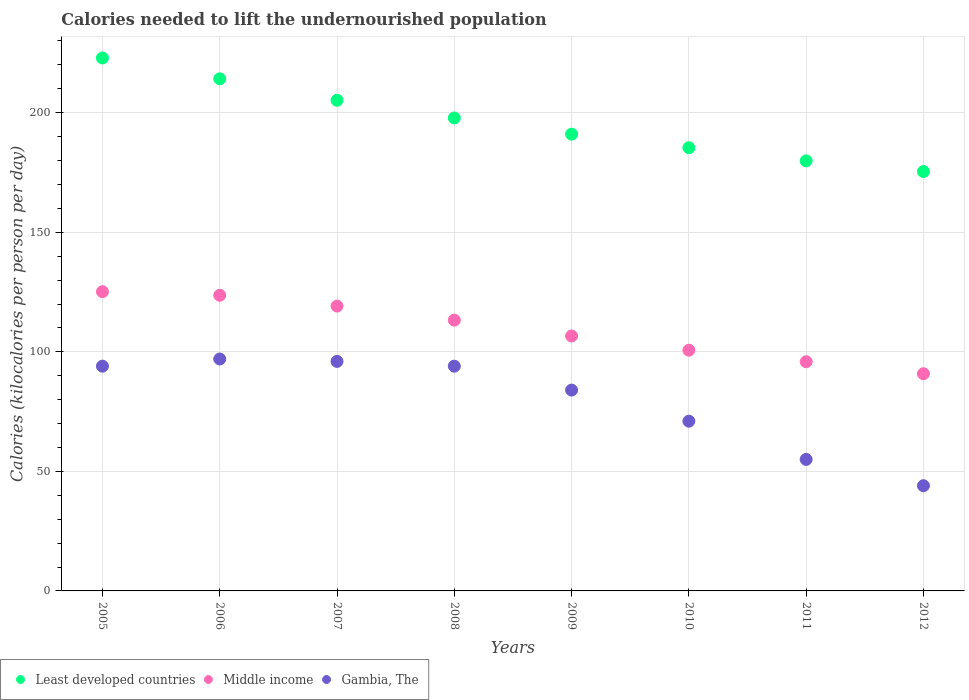How many different coloured dotlines are there?
Provide a succinct answer. 3. What is the total calories needed to lift the undernourished population in Least developed countries in 2010?
Your response must be concise. 185.38. Across all years, what is the maximum total calories needed to lift the undernourished population in Least developed countries?
Your answer should be compact. 222.9. Across all years, what is the minimum total calories needed to lift the undernourished population in Least developed countries?
Offer a terse response. 175.4. In which year was the total calories needed to lift the undernourished population in Gambia, The minimum?
Give a very brief answer. 2012. What is the total total calories needed to lift the undernourished population in Middle income in the graph?
Provide a short and direct response. 875.21. What is the difference between the total calories needed to lift the undernourished population in Gambia, The in 2008 and that in 2010?
Offer a very short reply. 23. What is the difference between the total calories needed to lift the undernourished population in Least developed countries in 2011 and the total calories needed to lift the undernourished population in Gambia, The in 2007?
Make the answer very short. 83.88. What is the average total calories needed to lift the undernourished population in Gambia, The per year?
Ensure brevity in your answer.  79.38. In the year 2010, what is the difference between the total calories needed to lift the undernourished population in Least developed countries and total calories needed to lift the undernourished population in Gambia, The?
Offer a very short reply. 114.38. What is the ratio of the total calories needed to lift the undernourished population in Gambia, The in 2010 to that in 2011?
Offer a very short reply. 1.29. Is the difference between the total calories needed to lift the undernourished population in Least developed countries in 2008 and 2009 greater than the difference between the total calories needed to lift the undernourished population in Gambia, The in 2008 and 2009?
Offer a terse response. No. What is the difference between the highest and the second highest total calories needed to lift the undernourished population in Gambia, The?
Offer a terse response. 1. What is the difference between the highest and the lowest total calories needed to lift the undernourished population in Least developed countries?
Keep it short and to the point. 47.5. In how many years, is the total calories needed to lift the undernourished population in Middle income greater than the average total calories needed to lift the undernourished population in Middle income taken over all years?
Provide a short and direct response. 4. Is the total calories needed to lift the undernourished population in Gambia, The strictly greater than the total calories needed to lift the undernourished population in Middle income over the years?
Your answer should be compact. No. Is the total calories needed to lift the undernourished population in Least developed countries strictly less than the total calories needed to lift the undernourished population in Gambia, The over the years?
Make the answer very short. No. How many dotlines are there?
Provide a short and direct response. 3. Does the graph contain any zero values?
Provide a short and direct response. No. Where does the legend appear in the graph?
Your answer should be compact. Bottom left. How many legend labels are there?
Keep it short and to the point. 3. What is the title of the graph?
Your answer should be compact. Calories needed to lift the undernourished population. What is the label or title of the Y-axis?
Your answer should be very brief. Calories (kilocalories per person per day). What is the Calories (kilocalories per person per day) in Least developed countries in 2005?
Give a very brief answer. 222.9. What is the Calories (kilocalories per person per day) in Middle income in 2005?
Provide a succinct answer. 125.16. What is the Calories (kilocalories per person per day) of Gambia, The in 2005?
Your answer should be very brief. 94. What is the Calories (kilocalories per person per day) in Least developed countries in 2006?
Your response must be concise. 214.18. What is the Calories (kilocalories per person per day) in Middle income in 2006?
Give a very brief answer. 123.65. What is the Calories (kilocalories per person per day) of Gambia, The in 2006?
Give a very brief answer. 97. What is the Calories (kilocalories per person per day) in Least developed countries in 2007?
Give a very brief answer. 205.2. What is the Calories (kilocalories per person per day) of Middle income in 2007?
Your answer should be very brief. 119.14. What is the Calories (kilocalories per person per day) of Gambia, The in 2007?
Offer a very short reply. 96. What is the Calories (kilocalories per person per day) of Least developed countries in 2008?
Your answer should be compact. 197.82. What is the Calories (kilocalories per person per day) in Middle income in 2008?
Offer a terse response. 113.26. What is the Calories (kilocalories per person per day) in Gambia, The in 2008?
Offer a very short reply. 94. What is the Calories (kilocalories per person per day) in Least developed countries in 2009?
Provide a short and direct response. 191.04. What is the Calories (kilocalories per person per day) of Middle income in 2009?
Give a very brief answer. 106.62. What is the Calories (kilocalories per person per day) of Least developed countries in 2010?
Your answer should be very brief. 185.38. What is the Calories (kilocalories per person per day) in Middle income in 2010?
Offer a very short reply. 100.68. What is the Calories (kilocalories per person per day) in Least developed countries in 2011?
Your answer should be very brief. 179.88. What is the Calories (kilocalories per person per day) in Middle income in 2011?
Your answer should be very brief. 95.87. What is the Calories (kilocalories per person per day) of Least developed countries in 2012?
Your answer should be compact. 175.4. What is the Calories (kilocalories per person per day) in Middle income in 2012?
Your answer should be very brief. 90.84. Across all years, what is the maximum Calories (kilocalories per person per day) of Least developed countries?
Ensure brevity in your answer.  222.9. Across all years, what is the maximum Calories (kilocalories per person per day) in Middle income?
Offer a terse response. 125.16. Across all years, what is the maximum Calories (kilocalories per person per day) of Gambia, The?
Your answer should be very brief. 97. Across all years, what is the minimum Calories (kilocalories per person per day) of Least developed countries?
Ensure brevity in your answer.  175.4. Across all years, what is the minimum Calories (kilocalories per person per day) in Middle income?
Keep it short and to the point. 90.84. Across all years, what is the minimum Calories (kilocalories per person per day) in Gambia, The?
Give a very brief answer. 44. What is the total Calories (kilocalories per person per day) in Least developed countries in the graph?
Make the answer very short. 1571.8. What is the total Calories (kilocalories per person per day) in Middle income in the graph?
Offer a very short reply. 875.21. What is the total Calories (kilocalories per person per day) of Gambia, The in the graph?
Give a very brief answer. 635. What is the difference between the Calories (kilocalories per person per day) in Least developed countries in 2005 and that in 2006?
Give a very brief answer. 8.72. What is the difference between the Calories (kilocalories per person per day) of Middle income in 2005 and that in 2006?
Ensure brevity in your answer.  1.51. What is the difference between the Calories (kilocalories per person per day) of Least developed countries in 2005 and that in 2007?
Your answer should be very brief. 17.7. What is the difference between the Calories (kilocalories per person per day) in Middle income in 2005 and that in 2007?
Provide a succinct answer. 6.03. What is the difference between the Calories (kilocalories per person per day) of Gambia, The in 2005 and that in 2007?
Give a very brief answer. -2. What is the difference between the Calories (kilocalories per person per day) of Least developed countries in 2005 and that in 2008?
Provide a succinct answer. 25.08. What is the difference between the Calories (kilocalories per person per day) in Middle income in 2005 and that in 2008?
Offer a very short reply. 11.91. What is the difference between the Calories (kilocalories per person per day) of Least developed countries in 2005 and that in 2009?
Provide a succinct answer. 31.87. What is the difference between the Calories (kilocalories per person per day) in Middle income in 2005 and that in 2009?
Make the answer very short. 18.54. What is the difference between the Calories (kilocalories per person per day) in Least developed countries in 2005 and that in 2010?
Provide a succinct answer. 37.52. What is the difference between the Calories (kilocalories per person per day) of Middle income in 2005 and that in 2010?
Your answer should be very brief. 24.49. What is the difference between the Calories (kilocalories per person per day) of Gambia, The in 2005 and that in 2010?
Give a very brief answer. 23. What is the difference between the Calories (kilocalories per person per day) of Least developed countries in 2005 and that in 2011?
Offer a very short reply. 43.03. What is the difference between the Calories (kilocalories per person per day) in Middle income in 2005 and that in 2011?
Keep it short and to the point. 29.29. What is the difference between the Calories (kilocalories per person per day) of Least developed countries in 2005 and that in 2012?
Make the answer very short. 47.5. What is the difference between the Calories (kilocalories per person per day) in Middle income in 2005 and that in 2012?
Offer a terse response. 34.33. What is the difference between the Calories (kilocalories per person per day) of Gambia, The in 2005 and that in 2012?
Your answer should be compact. 50. What is the difference between the Calories (kilocalories per person per day) in Least developed countries in 2006 and that in 2007?
Your answer should be compact. 8.98. What is the difference between the Calories (kilocalories per person per day) of Middle income in 2006 and that in 2007?
Make the answer very short. 4.51. What is the difference between the Calories (kilocalories per person per day) in Gambia, The in 2006 and that in 2007?
Your answer should be very brief. 1. What is the difference between the Calories (kilocalories per person per day) in Least developed countries in 2006 and that in 2008?
Provide a short and direct response. 16.36. What is the difference between the Calories (kilocalories per person per day) of Middle income in 2006 and that in 2008?
Your answer should be very brief. 10.39. What is the difference between the Calories (kilocalories per person per day) of Least developed countries in 2006 and that in 2009?
Give a very brief answer. 23.15. What is the difference between the Calories (kilocalories per person per day) in Middle income in 2006 and that in 2009?
Give a very brief answer. 17.03. What is the difference between the Calories (kilocalories per person per day) of Gambia, The in 2006 and that in 2009?
Your answer should be very brief. 13. What is the difference between the Calories (kilocalories per person per day) of Least developed countries in 2006 and that in 2010?
Make the answer very short. 28.8. What is the difference between the Calories (kilocalories per person per day) in Middle income in 2006 and that in 2010?
Offer a terse response. 22.97. What is the difference between the Calories (kilocalories per person per day) of Least developed countries in 2006 and that in 2011?
Ensure brevity in your answer.  34.3. What is the difference between the Calories (kilocalories per person per day) of Middle income in 2006 and that in 2011?
Provide a succinct answer. 27.78. What is the difference between the Calories (kilocalories per person per day) in Least developed countries in 2006 and that in 2012?
Give a very brief answer. 38.78. What is the difference between the Calories (kilocalories per person per day) of Middle income in 2006 and that in 2012?
Ensure brevity in your answer.  32.81. What is the difference between the Calories (kilocalories per person per day) of Least developed countries in 2007 and that in 2008?
Keep it short and to the point. 7.38. What is the difference between the Calories (kilocalories per person per day) of Middle income in 2007 and that in 2008?
Keep it short and to the point. 5.88. What is the difference between the Calories (kilocalories per person per day) of Gambia, The in 2007 and that in 2008?
Provide a succinct answer. 2. What is the difference between the Calories (kilocalories per person per day) of Least developed countries in 2007 and that in 2009?
Your answer should be compact. 14.17. What is the difference between the Calories (kilocalories per person per day) of Middle income in 2007 and that in 2009?
Give a very brief answer. 12.51. What is the difference between the Calories (kilocalories per person per day) of Gambia, The in 2007 and that in 2009?
Provide a short and direct response. 12. What is the difference between the Calories (kilocalories per person per day) in Least developed countries in 2007 and that in 2010?
Keep it short and to the point. 19.82. What is the difference between the Calories (kilocalories per person per day) in Middle income in 2007 and that in 2010?
Give a very brief answer. 18.46. What is the difference between the Calories (kilocalories per person per day) in Gambia, The in 2007 and that in 2010?
Your answer should be very brief. 25. What is the difference between the Calories (kilocalories per person per day) of Least developed countries in 2007 and that in 2011?
Give a very brief answer. 25.32. What is the difference between the Calories (kilocalories per person per day) in Middle income in 2007 and that in 2011?
Your response must be concise. 23.27. What is the difference between the Calories (kilocalories per person per day) in Least developed countries in 2007 and that in 2012?
Offer a very short reply. 29.8. What is the difference between the Calories (kilocalories per person per day) of Middle income in 2007 and that in 2012?
Your response must be concise. 28.3. What is the difference between the Calories (kilocalories per person per day) of Gambia, The in 2007 and that in 2012?
Your answer should be very brief. 52. What is the difference between the Calories (kilocalories per person per day) of Least developed countries in 2008 and that in 2009?
Provide a short and direct response. 6.79. What is the difference between the Calories (kilocalories per person per day) in Middle income in 2008 and that in 2009?
Your response must be concise. 6.63. What is the difference between the Calories (kilocalories per person per day) of Least developed countries in 2008 and that in 2010?
Your answer should be very brief. 12.44. What is the difference between the Calories (kilocalories per person per day) in Middle income in 2008 and that in 2010?
Ensure brevity in your answer.  12.58. What is the difference between the Calories (kilocalories per person per day) of Least developed countries in 2008 and that in 2011?
Your answer should be compact. 17.95. What is the difference between the Calories (kilocalories per person per day) in Middle income in 2008 and that in 2011?
Provide a succinct answer. 17.39. What is the difference between the Calories (kilocalories per person per day) of Gambia, The in 2008 and that in 2011?
Offer a terse response. 39. What is the difference between the Calories (kilocalories per person per day) of Least developed countries in 2008 and that in 2012?
Offer a very short reply. 22.42. What is the difference between the Calories (kilocalories per person per day) of Middle income in 2008 and that in 2012?
Ensure brevity in your answer.  22.42. What is the difference between the Calories (kilocalories per person per day) in Least developed countries in 2009 and that in 2010?
Provide a short and direct response. 5.65. What is the difference between the Calories (kilocalories per person per day) of Middle income in 2009 and that in 2010?
Provide a succinct answer. 5.95. What is the difference between the Calories (kilocalories per person per day) of Least developed countries in 2009 and that in 2011?
Keep it short and to the point. 11.16. What is the difference between the Calories (kilocalories per person per day) in Middle income in 2009 and that in 2011?
Make the answer very short. 10.76. What is the difference between the Calories (kilocalories per person per day) in Least developed countries in 2009 and that in 2012?
Provide a succinct answer. 15.63. What is the difference between the Calories (kilocalories per person per day) of Middle income in 2009 and that in 2012?
Your answer should be very brief. 15.79. What is the difference between the Calories (kilocalories per person per day) in Least developed countries in 2010 and that in 2011?
Your response must be concise. 5.5. What is the difference between the Calories (kilocalories per person per day) of Middle income in 2010 and that in 2011?
Keep it short and to the point. 4.81. What is the difference between the Calories (kilocalories per person per day) of Gambia, The in 2010 and that in 2011?
Your answer should be very brief. 16. What is the difference between the Calories (kilocalories per person per day) in Least developed countries in 2010 and that in 2012?
Give a very brief answer. 9.98. What is the difference between the Calories (kilocalories per person per day) of Middle income in 2010 and that in 2012?
Give a very brief answer. 9.84. What is the difference between the Calories (kilocalories per person per day) of Least developed countries in 2011 and that in 2012?
Your answer should be compact. 4.47. What is the difference between the Calories (kilocalories per person per day) of Middle income in 2011 and that in 2012?
Provide a short and direct response. 5.03. What is the difference between the Calories (kilocalories per person per day) of Least developed countries in 2005 and the Calories (kilocalories per person per day) of Middle income in 2006?
Offer a very short reply. 99.25. What is the difference between the Calories (kilocalories per person per day) of Least developed countries in 2005 and the Calories (kilocalories per person per day) of Gambia, The in 2006?
Your response must be concise. 125.9. What is the difference between the Calories (kilocalories per person per day) in Middle income in 2005 and the Calories (kilocalories per person per day) in Gambia, The in 2006?
Your response must be concise. 28.16. What is the difference between the Calories (kilocalories per person per day) in Least developed countries in 2005 and the Calories (kilocalories per person per day) in Middle income in 2007?
Make the answer very short. 103.77. What is the difference between the Calories (kilocalories per person per day) of Least developed countries in 2005 and the Calories (kilocalories per person per day) of Gambia, The in 2007?
Your answer should be very brief. 126.9. What is the difference between the Calories (kilocalories per person per day) of Middle income in 2005 and the Calories (kilocalories per person per day) of Gambia, The in 2007?
Offer a very short reply. 29.16. What is the difference between the Calories (kilocalories per person per day) in Least developed countries in 2005 and the Calories (kilocalories per person per day) in Middle income in 2008?
Your answer should be very brief. 109.65. What is the difference between the Calories (kilocalories per person per day) in Least developed countries in 2005 and the Calories (kilocalories per person per day) in Gambia, The in 2008?
Offer a terse response. 128.9. What is the difference between the Calories (kilocalories per person per day) of Middle income in 2005 and the Calories (kilocalories per person per day) of Gambia, The in 2008?
Keep it short and to the point. 31.16. What is the difference between the Calories (kilocalories per person per day) of Least developed countries in 2005 and the Calories (kilocalories per person per day) of Middle income in 2009?
Give a very brief answer. 116.28. What is the difference between the Calories (kilocalories per person per day) in Least developed countries in 2005 and the Calories (kilocalories per person per day) in Gambia, The in 2009?
Your answer should be compact. 138.9. What is the difference between the Calories (kilocalories per person per day) of Middle income in 2005 and the Calories (kilocalories per person per day) of Gambia, The in 2009?
Give a very brief answer. 41.16. What is the difference between the Calories (kilocalories per person per day) of Least developed countries in 2005 and the Calories (kilocalories per person per day) of Middle income in 2010?
Your answer should be compact. 122.23. What is the difference between the Calories (kilocalories per person per day) in Least developed countries in 2005 and the Calories (kilocalories per person per day) in Gambia, The in 2010?
Your answer should be very brief. 151.9. What is the difference between the Calories (kilocalories per person per day) of Middle income in 2005 and the Calories (kilocalories per person per day) of Gambia, The in 2010?
Your response must be concise. 54.16. What is the difference between the Calories (kilocalories per person per day) in Least developed countries in 2005 and the Calories (kilocalories per person per day) in Middle income in 2011?
Your answer should be very brief. 127.04. What is the difference between the Calories (kilocalories per person per day) of Least developed countries in 2005 and the Calories (kilocalories per person per day) of Gambia, The in 2011?
Keep it short and to the point. 167.9. What is the difference between the Calories (kilocalories per person per day) of Middle income in 2005 and the Calories (kilocalories per person per day) of Gambia, The in 2011?
Offer a very short reply. 70.16. What is the difference between the Calories (kilocalories per person per day) in Least developed countries in 2005 and the Calories (kilocalories per person per day) in Middle income in 2012?
Give a very brief answer. 132.07. What is the difference between the Calories (kilocalories per person per day) of Least developed countries in 2005 and the Calories (kilocalories per person per day) of Gambia, The in 2012?
Offer a terse response. 178.9. What is the difference between the Calories (kilocalories per person per day) in Middle income in 2005 and the Calories (kilocalories per person per day) in Gambia, The in 2012?
Give a very brief answer. 81.16. What is the difference between the Calories (kilocalories per person per day) in Least developed countries in 2006 and the Calories (kilocalories per person per day) in Middle income in 2007?
Provide a short and direct response. 95.05. What is the difference between the Calories (kilocalories per person per day) in Least developed countries in 2006 and the Calories (kilocalories per person per day) in Gambia, The in 2007?
Provide a short and direct response. 118.18. What is the difference between the Calories (kilocalories per person per day) in Middle income in 2006 and the Calories (kilocalories per person per day) in Gambia, The in 2007?
Your answer should be compact. 27.65. What is the difference between the Calories (kilocalories per person per day) in Least developed countries in 2006 and the Calories (kilocalories per person per day) in Middle income in 2008?
Offer a terse response. 100.93. What is the difference between the Calories (kilocalories per person per day) of Least developed countries in 2006 and the Calories (kilocalories per person per day) of Gambia, The in 2008?
Your answer should be compact. 120.18. What is the difference between the Calories (kilocalories per person per day) in Middle income in 2006 and the Calories (kilocalories per person per day) in Gambia, The in 2008?
Provide a short and direct response. 29.65. What is the difference between the Calories (kilocalories per person per day) in Least developed countries in 2006 and the Calories (kilocalories per person per day) in Middle income in 2009?
Provide a succinct answer. 107.56. What is the difference between the Calories (kilocalories per person per day) in Least developed countries in 2006 and the Calories (kilocalories per person per day) in Gambia, The in 2009?
Make the answer very short. 130.18. What is the difference between the Calories (kilocalories per person per day) in Middle income in 2006 and the Calories (kilocalories per person per day) in Gambia, The in 2009?
Your response must be concise. 39.65. What is the difference between the Calories (kilocalories per person per day) of Least developed countries in 2006 and the Calories (kilocalories per person per day) of Middle income in 2010?
Offer a terse response. 113.5. What is the difference between the Calories (kilocalories per person per day) of Least developed countries in 2006 and the Calories (kilocalories per person per day) of Gambia, The in 2010?
Keep it short and to the point. 143.18. What is the difference between the Calories (kilocalories per person per day) in Middle income in 2006 and the Calories (kilocalories per person per day) in Gambia, The in 2010?
Provide a short and direct response. 52.65. What is the difference between the Calories (kilocalories per person per day) in Least developed countries in 2006 and the Calories (kilocalories per person per day) in Middle income in 2011?
Your answer should be compact. 118.31. What is the difference between the Calories (kilocalories per person per day) in Least developed countries in 2006 and the Calories (kilocalories per person per day) in Gambia, The in 2011?
Provide a succinct answer. 159.18. What is the difference between the Calories (kilocalories per person per day) of Middle income in 2006 and the Calories (kilocalories per person per day) of Gambia, The in 2011?
Make the answer very short. 68.65. What is the difference between the Calories (kilocalories per person per day) of Least developed countries in 2006 and the Calories (kilocalories per person per day) of Middle income in 2012?
Ensure brevity in your answer.  123.35. What is the difference between the Calories (kilocalories per person per day) in Least developed countries in 2006 and the Calories (kilocalories per person per day) in Gambia, The in 2012?
Provide a short and direct response. 170.18. What is the difference between the Calories (kilocalories per person per day) of Middle income in 2006 and the Calories (kilocalories per person per day) of Gambia, The in 2012?
Provide a succinct answer. 79.65. What is the difference between the Calories (kilocalories per person per day) in Least developed countries in 2007 and the Calories (kilocalories per person per day) in Middle income in 2008?
Offer a terse response. 91.95. What is the difference between the Calories (kilocalories per person per day) of Least developed countries in 2007 and the Calories (kilocalories per person per day) of Gambia, The in 2008?
Offer a terse response. 111.2. What is the difference between the Calories (kilocalories per person per day) of Middle income in 2007 and the Calories (kilocalories per person per day) of Gambia, The in 2008?
Offer a terse response. 25.14. What is the difference between the Calories (kilocalories per person per day) of Least developed countries in 2007 and the Calories (kilocalories per person per day) of Middle income in 2009?
Offer a terse response. 98.58. What is the difference between the Calories (kilocalories per person per day) of Least developed countries in 2007 and the Calories (kilocalories per person per day) of Gambia, The in 2009?
Offer a terse response. 121.2. What is the difference between the Calories (kilocalories per person per day) of Middle income in 2007 and the Calories (kilocalories per person per day) of Gambia, The in 2009?
Offer a terse response. 35.14. What is the difference between the Calories (kilocalories per person per day) in Least developed countries in 2007 and the Calories (kilocalories per person per day) in Middle income in 2010?
Your answer should be very brief. 104.52. What is the difference between the Calories (kilocalories per person per day) in Least developed countries in 2007 and the Calories (kilocalories per person per day) in Gambia, The in 2010?
Keep it short and to the point. 134.2. What is the difference between the Calories (kilocalories per person per day) of Middle income in 2007 and the Calories (kilocalories per person per day) of Gambia, The in 2010?
Your answer should be compact. 48.14. What is the difference between the Calories (kilocalories per person per day) of Least developed countries in 2007 and the Calories (kilocalories per person per day) of Middle income in 2011?
Give a very brief answer. 109.33. What is the difference between the Calories (kilocalories per person per day) of Least developed countries in 2007 and the Calories (kilocalories per person per day) of Gambia, The in 2011?
Your answer should be compact. 150.2. What is the difference between the Calories (kilocalories per person per day) of Middle income in 2007 and the Calories (kilocalories per person per day) of Gambia, The in 2011?
Offer a very short reply. 64.14. What is the difference between the Calories (kilocalories per person per day) of Least developed countries in 2007 and the Calories (kilocalories per person per day) of Middle income in 2012?
Provide a succinct answer. 114.37. What is the difference between the Calories (kilocalories per person per day) in Least developed countries in 2007 and the Calories (kilocalories per person per day) in Gambia, The in 2012?
Provide a succinct answer. 161.2. What is the difference between the Calories (kilocalories per person per day) in Middle income in 2007 and the Calories (kilocalories per person per day) in Gambia, The in 2012?
Make the answer very short. 75.14. What is the difference between the Calories (kilocalories per person per day) of Least developed countries in 2008 and the Calories (kilocalories per person per day) of Middle income in 2009?
Offer a terse response. 91.2. What is the difference between the Calories (kilocalories per person per day) of Least developed countries in 2008 and the Calories (kilocalories per person per day) of Gambia, The in 2009?
Make the answer very short. 113.82. What is the difference between the Calories (kilocalories per person per day) of Middle income in 2008 and the Calories (kilocalories per person per day) of Gambia, The in 2009?
Your answer should be compact. 29.26. What is the difference between the Calories (kilocalories per person per day) of Least developed countries in 2008 and the Calories (kilocalories per person per day) of Middle income in 2010?
Give a very brief answer. 97.14. What is the difference between the Calories (kilocalories per person per day) of Least developed countries in 2008 and the Calories (kilocalories per person per day) of Gambia, The in 2010?
Your response must be concise. 126.82. What is the difference between the Calories (kilocalories per person per day) of Middle income in 2008 and the Calories (kilocalories per person per day) of Gambia, The in 2010?
Ensure brevity in your answer.  42.26. What is the difference between the Calories (kilocalories per person per day) in Least developed countries in 2008 and the Calories (kilocalories per person per day) in Middle income in 2011?
Ensure brevity in your answer.  101.95. What is the difference between the Calories (kilocalories per person per day) of Least developed countries in 2008 and the Calories (kilocalories per person per day) of Gambia, The in 2011?
Your answer should be very brief. 142.82. What is the difference between the Calories (kilocalories per person per day) of Middle income in 2008 and the Calories (kilocalories per person per day) of Gambia, The in 2011?
Ensure brevity in your answer.  58.26. What is the difference between the Calories (kilocalories per person per day) of Least developed countries in 2008 and the Calories (kilocalories per person per day) of Middle income in 2012?
Your response must be concise. 106.99. What is the difference between the Calories (kilocalories per person per day) of Least developed countries in 2008 and the Calories (kilocalories per person per day) of Gambia, The in 2012?
Keep it short and to the point. 153.82. What is the difference between the Calories (kilocalories per person per day) of Middle income in 2008 and the Calories (kilocalories per person per day) of Gambia, The in 2012?
Ensure brevity in your answer.  69.26. What is the difference between the Calories (kilocalories per person per day) of Least developed countries in 2009 and the Calories (kilocalories per person per day) of Middle income in 2010?
Provide a succinct answer. 90.36. What is the difference between the Calories (kilocalories per person per day) in Least developed countries in 2009 and the Calories (kilocalories per person per day) in Gambia, The in 2010?
Keep it short and to the point. 120.04. What is the difference between the Calories (kilocalories per person per day) of Middle income in 2009 and the Calories (kilocalories per person per day) of Gambia, The in 2010?
Make the answer very short. 35.62. What is the difference between the Calories (kilocalories per person per day) of Least developed countries in 2009 and the Calories (kilocalories per person per day) of Middle income in 2011?
Your response must be concise. 95.17. What is the difference between the Calories (kilocalories per person per day) in Least developed countries in 2009 and the Calories (kilocalories per person per day) in Gambia, The in 2011?
Provide a short and direct response. 136.04. What is the difference between the Calories (kilocalories per person per day) of Middle income in 2009 and the Calories (kilocalories per person per day) of Gambia, The in 2011?
Offer a very short reply. 51.62. What is the difference between the Calories (kilocalories per person per day) in Least developed countries in 2009 and the Calories (kilocalories per person per day) in Middle income in 2012?
Make the answer very short. 100.2. What is the difference between the Calories (kilocalories per person per day) of Least developed countries in 2009 and the Calories (kilocalories per person per day) of Gambia, The in 2012?
Provide a short and direct response. 147.04. What is the difference between the Calories (kilocalories per person per day) in Middle income in 2009 and the Calories (kilocalories per person per day) in Gambia, The in 2012?
Provide a short and direct response. 62.62. What is the difference between the Calories (kilocalories per person per day) of Least developed countries in 2010 and the Calories (kilocalories per person per day) of Middle income in 2011?
Your answer should be compact. 89.51. What is the difference between the Calories (kilocalories per person per day) in Least developed countries in 2010 and the Calories (kilocalories per person per day) in Gambia, The in 2011?
Your answer should be very brief. 130.38. What is the difference between the Calories (kilocalories per person per day) of Middle income in 2010 and the Calories (kilocalories per person per day) of Gambia, The in 2011?
Your answer should be very brief. 45.68. What is the difference between the Calories (kilocalories per person per day) in Least developed countries in 2010 and the Calories (kilocalories per person per day) in Middle income in 2012?
Give a very brief answer. 94.55. What is the difference between the Calories (kilocalories per person per day) in Least developed countries in 2010 and the Calories (kilocalories per person per day) in Gambia, The in 2012?
Make the answer very short. 141.38. What is the difference between the Calories (kilocalories per person per day) of Middle income in 2010 and the Calories (kilocalories per person per day) of Gambia, The in 2012?
Provide a short and direct response. 56.68. What is the difference between the Calories (kilocalories per person per day) in Least developed countries in 2011 and the Calories (kilocalories per person per day) in Middle income in 2012?
Offer a very short reply. 89.04. What is the difference between the Calories (kilocalories per person per day) in Least developed countries in 2011 and the Calories (kilocalories per person per day) in Gambia, The in 2012?
Your answer should be very brief. 135.88. What is the difference between the Calories (kilocalories per person per day) in Middle income in 2011 and the Calories (kilocalories per person per day) in Gambia, The in 2012?
Make the answer very short. 51.87. What is the average Calories (kilocalories per person per day) in Least developed countries per year?
Keep it short and to the point. 196.48. What is the average Calories (kilocalories per person per day) in Middle income per year?
Make the answer very short. 109.4. What is the average Calories (kilocalories per person per day) of Gambia, The per year?
Your response must be concise. 79.38. In the year 2005, what is the difference between the Calories (kilocalories per person per day) in Least developed countries and Calories (kilocalories per person per day) in Middle income?
Offer a terse response. 97.74. In the year 2005, what is the difference between the Calories (kilocalories per person per day) of Least developed countries and Calories (kilocalories per person per day) of Gambia, The?
Offer a terse response. 128.9. In the year 2005, what is the difference between the Calories (kilocalories per person per day) in Middle income and Calories (kilocalories per person per day) in Gambia, The?
Provide a short and direct response. 31.16. In the year 2006, what is the difference between the Calories (kilocalories per person per day) in Least developed countries and Calories (kilocalories per person per day) in Middle income?
Offer a very short reply. 90.53. In the year 2006, what is the difference between the Calories (kilocalories per person per day) of Least developed countries and Calories (kilocalories per person per day) of Gambia, The?
Provide a short and direct response. 117.18. In the year 2006, what is the difference between the Calories (kilocalories per person per day) in Middle income and Calories (kilocalories per person per day) in Gambia, The?
Your answer should be compact. 26.65. In the year 2007, what is the difference between the Calories (kilocalories per person per day) in Least developed countries and Calories (kilocalories per person per day) in Middle income?
Keep it short and to the point. 86.06. In the year 2007, what is the difference between the Calories (kilocalories per person per day) in Least developed countries and Calories (kilocalories per person per day) in Gambia, The?
Your answer should be compact. 109.2. In the year 2007, what is the difference between the Calories (kilocalories per person per day) in Middle income and Calories (kilocalories per person per day) in Gambia, The?
Keep it short and to the point. 23.14. In the year 2008, what is the difference between the Calories (kilocalories per person per day) in Least developed countries and Calories (kilocalories per person per day) in Middle income?
Ensure brevity in your answer.  84.57. In the year 2008, what is the difference between the Calories (kilocalories per person per day) in Least developed countries and Calories (kilocalories per person per day) in Gambia, The?
Keep it short and to the point. 103.82. In the year 2008, what is the difference between the Calories (kilocalories per person per day) of Middle income and Calories (kilocalories per person per day) of Gambia, The?
Make the answer very short. 19.26. In the year 2009, what is the difference between the Calories (kilocalories per person per day) in Least developed countries and Calories (kilocalories per person per day) in Middle income?
Your answer should be compact. 84.41. In the year 2009, what is the difference between the Calories (kilocalories per person per day) of Least developed countries and Calories (kilocalories per person per day) of Gambia, The?
Provide a short and direct response. 107.04. In the year 2009, what is the difference between the Calories (kilocalories per person per day) of Middle income and Calories (kilocalories per person per day) of Gambia, The?
Provide a short and direct response. 22.62. In the year 2010, what is the difference between the Calories (kilocalories per person per day) of Least developed countries and Calories (kilocalories per person per day) of Middle income?
Provide a short and direct response. 84.7. In the year 2010, what is the difference between the Calories (kilocalories per person per day) of Least developed countries and Calories (kilocalories per person per day) of Gambia, The?
Make the answer very short. 114.38. In the year 2010, what is the difference between the Calories (kilocalories per person per day) of Middle income and Calories (kilocalories per person per day) of Gambia, The?
Keep it short and to the point. 29.68. In the year 2011, what is the difference between the Calories (kilocalories per person per day) of Least developed countries and Calories (kilocalories per person per day) of Middle income?
Ensure brevity in your answer.  84.01. In the year 2011, what is the difference between the Calories (kilocalories per person per day) in Least developed countries and Calories (kilocalories per person per day) in Gambia, The?
Offer a very short reply. 124.88. In the year 2011, what is the difference between the Calories (kilocalories per person per day) in Middle income and Calories (kilocalories per person per day) in Gambia, The?
Your response must be concise. 40.87. In the year 2012, what is the difference between the Calories (kilocalories per person per day) in Least developed countries and Calories (kilocalories per person per day) in Middle income?
Offer a terse response. 84.57. In the year 2012, what is the difference between the Calories (kilocalories per person per day) in Least developed countries and Calories (kilocalories per person per day) in Gambia, The?
Your answer should be very brief. 131.4. In the year 2012, what is the difference between the Calories (kilocalories per person per day) in Middle income and Calories (kilocalories per person per day) in Gambia, The?
Give a very brief answer. 46.84. What is the ratio of the Calories (kilocalories per person per day) in Least developed countries in 2005 to that in 2006?
Keep it short and to the point. 1.04. What is the ratio of the Calories (kilocalories per person per day) of Middle income in 2005 to that in 2006?
Offer a terse response. 1.01. What is the ratio of the Calories (kilocalories per person per day) of Gambia, The in 2005 to that in 2006?
Offer a terse response. 0.97. What is the ratio of the Calories (kilocalories per person per day) of Least developed countries in 2005 to that in 2007?
Ensure brevity in your answer.  1.09. What is the ratio of the Calories (kilocalories per person per day) of Middle income in 2005 to that in 2007?
Offer a terse response. 1.05. What is the ratio of the Calories (kilocalories per person per day) of Gambia, The in 2005 to that in 2007?
Ensure brevity in your answer.  0.98. What is the ratio of the Calories (kilocalories per person per day) in Least developed countries in 2005 to that in 2008?
Keep it short and to the point. 1.13. What is the ratio of the Calories (kilocalories per person per day) in Middle income in 2005 to that in 2008?
Offer a very short reply. 1.11. What is the ratio of the Calories (kilocalories per person per day) of Least developed countries in 2005 to that in 2009?
Offer a very short reply. 1.17. What is the ratio of the Calories (kilocalories per person per day) of Middle income in 2005 to that in 2009?
Provide a succinct answer. 1.17. What is the ratio of the Calories (kilocalories per person per day) in Gambia, The in 2005 to that in 2009?
Your answer should be very brief. 1.12. What is the ratio of the Calories (kilocalories per person per day) in Least developed countries in 2005 to that in 2010?
Your answer should be very brief. 1.2. What is the ratio of the Calories (kilocalories per person per day) in Middle income in 2005 to that in 2010?
Provide a succinct answer. 1.24. What is the ratio of the Calories (kilocalories per person per day) of Gambia, The in 2005 to that in 2010?
Keep it short and to the point. 1.32. What is the ratio of the Calories (kilocalories per person per day) of Least developed countries in 2005 to that in 2011?
Offer a terse response. 1.24. What is the ratio of the Calories (kilocalories per person per day) in Middle income in 2005 to that in 2011?
Give a very brief answer. 1.31. What is the ratio of the Calories (kilocalories per person per day) in Gambia, The in 2005 to that in 2011?
Give a very brief answer. 1.71. What is the ratio of the Calories (kilocalories per person per day) of Least developed countries in 2005 to that in 2012?
Provide a short and direct response. 1.27. What is the ratio of the Calories (kilocalories per person per day) in Middle income in 2005 to that in 2012?
Make the answer very short. 1.38. What is the ratio of the Calories (kilocalories per person per day) in Gambia, The in 2005 to that in 2012?
Keep it short and to the point. 2.14. What is the ratio of the Calories (kilocalories per person per day) of Least developed countries in 2006 to that in 2007?
Provide a succinct answer. 1.04. What is the ratio of the Calories (kilocalories per person per day) in Middle income in 2006 to that in 2007?
Offer a terse response. 1.04. What is the ratio of the Calories (kilocalories per person per day) of Gambia, The in 2006 to that in 2007?
Provide a succinct answer. 1.01. What is the ratio of the Calories (kilocalories per person per day) of Least developed countries in 2006 to that in 2008?
Give a very brief answer. 1.08. What is the ratio of the Calories (kilocalories per person per day) of Middle income in 2006 to that in 2008?
Offer a very short reply. 1.09. What is the ratio of the Calories (kilocalories per person per day) in Gambia, The in 2006 to that in 2008?
Give a very brief answer. 1.03. What is the ratio of the Calories (kilocalories per person per day) in Least developed countries in 2006 to that in 2009?
Keep it short and to the point. 1.12. What is the ratio of the Calories (kilocalories per person per day) of Middle income in 2006 to that in 2009?
Offer a terse response. 1.16. What is the ratio of the Calories (kilocalories per person per day) in Gambia, The in 2006 to that in 2009?
Keep it short and to the point. 1.15. What is the ratio of the Calories (kilocalories per person per day) in Least developed countries in 2006 to that in 2010?
Your answer should be compact. 1.16. What is the ratio of the Calories (kilocalories per person per day) in Middle income in 2006 to that in 2010?
Make the answer very short. 1.23. What is the ratio of the Calories (kilocalories per person per day) of Gambia, The in 2006 to that in 2010?
Your answer should be compact. 1.37. What is the ratio of the Calories (kilocalories per person per day) in Least developed countries in 2006 to that in 2011?
Offer a very short reply. 1.19. What is the ratio of the Calories (kilocalories per person per day) of Middle income in 2006 to that in 2011?
Your answer should be very brief. 1.29. What is the ratio of the Calories (kilocalories per person per day) in Gambia, The in 2006 to that in 2011?
Your answer should be very brief. 1.76. What is the ratio of the Calories (kilocalories per person per day) of Least developed countries in 2006 to that in 2012?
Offer a terse response. 1.22. What is the ratio of the Calories (kilocalories per person per day) in Middle income in 2006 to that in 2012?
Keep it short and to the point. 1.36. What is the ratio of the Calories (kilocalories per person per day) in Gambia, The in 2006 to that in 2012?
Offer a very short reply. 2.2. What is the ratio of the Calories (kilocalories per person per day) of Least developed countries in 2007 to that in 2008?
Offer a terse response. 1.04. What is the ratio of the Calories (kilocalories per person per day) of Middle income in 2007 to that in 2008?
Give a very brief answer. 1.05. What is the ratio of the Calories (kilocalories per person per day) in Gambia, The in 2007 to that in 2008?
Ensure brevity in your answer.  1.02. What is the ratio of the Calories (kilocalories per person per day) of Least developed countries in 2007 to that in 2009?
Your answer should be very brief. 1.07. What is the ratio of the Calories (kilocalories per person per day) in Middle income in 2007 to that in 2009?
Make the answer very short. 1.12. What is the ratio of the Calories (kilocalories per person per day) in Least developed countries in 2007 to that in 2010?
Provide a succinct answer. 1.11. What is the ratio of the Calories (kilocalories per person per day) in Middle income in 2007 to that in 2010?
Offer a very short reply. 1.18. What is the ratio of the Calories (kilocalories per person per day) in Gambia, The in 2007 to that in 2010?
Ensure brevity in your answer.  1.35. What is the ratio of the Calories (kilocalories per person per day) of Least developed countries in 2007 to that in 2011?
Provide a short and direct response. 1.14. What is the ratio of the Calories (kilocalories per person per day) of Middle income in 2007 to that in 2011?
Provide a short and direct response. 1.24. What is the ratio of the Calories (kilocalories per person per day) in Gambia, The in 2007 to that in 2011?
Offer a very short reply. 1.75. What is the ratio of the Calories (kilocalories per person per day) of Least developed countries in 2007 to that in 2012?
Your response must be concise. 1.17. What is the ratio of the Calories (kilocalories per person per day) of Middle income in 2007 to that in 2012?
Offer a very short reply. 1.31. What is the ratio of the Calories (kilocalories per person per day) in Gambia, The in 2007 to that in 2012?
Provide a short and direct response. 2.18. What is the ratio of the Calories (kilocalories per person per day) in Least developed countries in 2008 to that in 2009?
Ensure brevity in your answer.  1.04. What is the ratio of the Calories (kilocalories per person per day) in Middle income in 2008 to that in 2009?
Your response must be concise. 1.06. What is the ratio of the Calories (kilocalories per person per day) in Gambia, The in 2008 to that in 2009?
Offer a terse response. 1.12. What is the ratio of the Calories (kilocalories per person per day) of Least developed countries in 2008 to that in 2010?
Provide a succinct answer. 1.07. What is the ratio of the Calories (kilocalories per person per day) of Middle income in 2008 to that in 2010?
Keep it short and to the point. 1.12. What is the ratio of the Calories (kilocalories per person per day) of Gambia, The in 2008 to that in 2010?
Your answer should be compact. 1.32. What is the ratio of the Calories (kilocalories per person per day) in Least developed countries in 2008 to that in 2011?
Your answer should be compact. 1.1. What is the ratio of the Calories (kilocalories per person per day) of Middle income in 2008 to that in 2011?
Ensure brevity in your answer.  1.18. What is the ratio of the Calories (kilocalories per person per day) of Gambia, The in 2008 to that in 2011?
Make the answer very short. 1.71. What is the ratio of the Calories (kilocalories per person per day) of Least developed countries in 2008 to that in 2012?
Keep it short and to the point. 1.13. What is the ratio of the Calories (kilocalories per person per day) in Middle income in 2008 to that in 2012?
Your answer should be compact. 1.25. What is the ratio of the Calories (kilocalories per person per day) in Gambia, The in 2008 to that in 2012?
Provide a short and direct response. 2.14. What is the ratio of the Calories (kilocalories per person per day) of Least developed countries in 2009 to that in 2010?
Keep it short and to the point. 1.03. What is the ratio of the Calories (kilocalories per person per day) in Middle income in 2009 to that in 2010?
Offer a very short reply. 1.06. What is the ratio of the Calories (kilocalories per person per day) of Gambia, The in 2009 to that in 2010?
Your answer should be compact. 1.18. What is the ratio of the Calories (kilocalories per person per day) of Least developed countries in 2009 to that in 2011?
Ensure brevity in your answer.  1.06. What is the ratio of the Calories (kilocalories per person per day) in Middle income in 2009 to that in 2011?
Your answer should be compact. 1.11. What is the ratio of the Calories (kilocalories per person per day) in Gambia, The in 2009 to that in 2011?
Offer a terse response. 1.53. What is the ratio of the Calories (kilocalories per person per day) in Least developed countries in 2009 to that in 2012?
Your answer should be compact. 1.09. What is the ratio of the Calories (kilocalories per person per day) in Middle income in 2009 to that in 2012?
Provide a short and direct response. 1.17. What is the ratio of the Calories (kilocalories per person per day) in Gambia, The in 2009 to that in 2012?
Your answer should be compact. 1.91. What is the ratio of the Calories (kilocalories per person per day) of Least developed countries in 2010 to that in 2011?
Keep it short and to the point. 1.03. What is the ratio of the Calories (kilocalories per person per day) in Middle income in 2010 to that in 2011?
Give a very brief answer. 1.05. What is the ratio of the Calories (kilocalories per person per day) in Gambia, The in 2010 to that in 2011?
Your answer should be compact. 1.29. What is the ratio of the Calories (kilocalories per person per day) in Least developed countries in 2010 to that in 2012?
Ensure brevity in your answer.  1.06. What is the ratio of the Calories (kilocalories per person per day) in Middle income in 2010 to that in 2012?
Your response must be concise. 1.11. What is the ratio of the Calories (kilocalories per person per day) in Gambia, The in 2010 to that in 2012?
Offer a very short reply. 1.61. What is the ratio of the Calories (kilocalories per person per day) of Least developed countries in 2011 to that in 2012?
Your answer should be very brief. 1.03. What is the ratio of the Calories (kilocalories per person per day) in Middle income in 2011 to that in 2012?
Keep it short and to the point. 1.06. What is the ratio of the Calories (kilocalories per person per day) of Gambia, The in 2011 to that in 2012?
Your answer should be compact. 1.25. What is the difference between the highest and the second highest Calories (kilocalories per person per day) of Least developed countries?
Provide a succinct answer. 8.72. What is the difference between the highest and the second highest Calories (kilocalories per person per day) in Middle income?
Keep it short and to the point. 1.51. What is the difference between the highest and the lowest Calories (kilocalories per person per day) in Least developed countries?
Ensure brevity in your answer.  47.5. What is the difference between the highest and the lowest Calories (kilocalories per person per day) in Middle income?
Give a very brief answer. 34.33. 